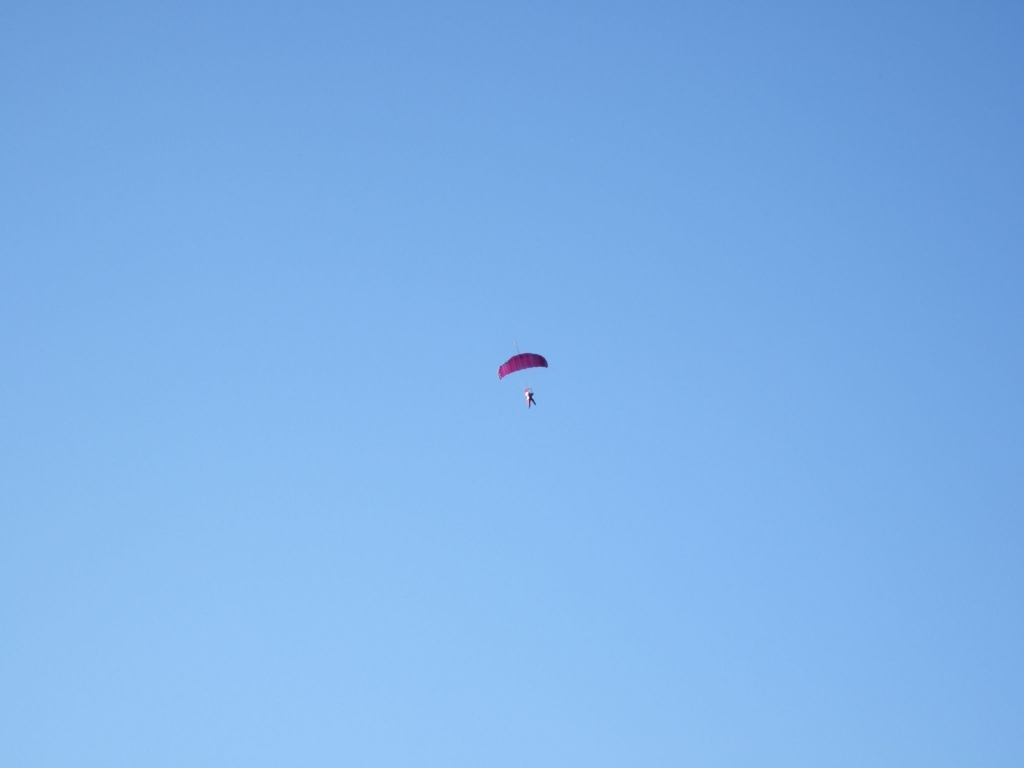What kind of parachute is visible in the image? The parachute shown in the image is a ram-air parachute, recognizable by its rectangular or tapered shape which helps provide better control and stability during flight. 